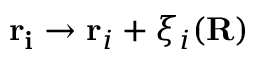Convert formula to latex. <formula><loc_0><loc_0><loc_500><loc_500>r _ { i } \rightarrow r _ { i } + \xi _ { i } ( R )</formula> 